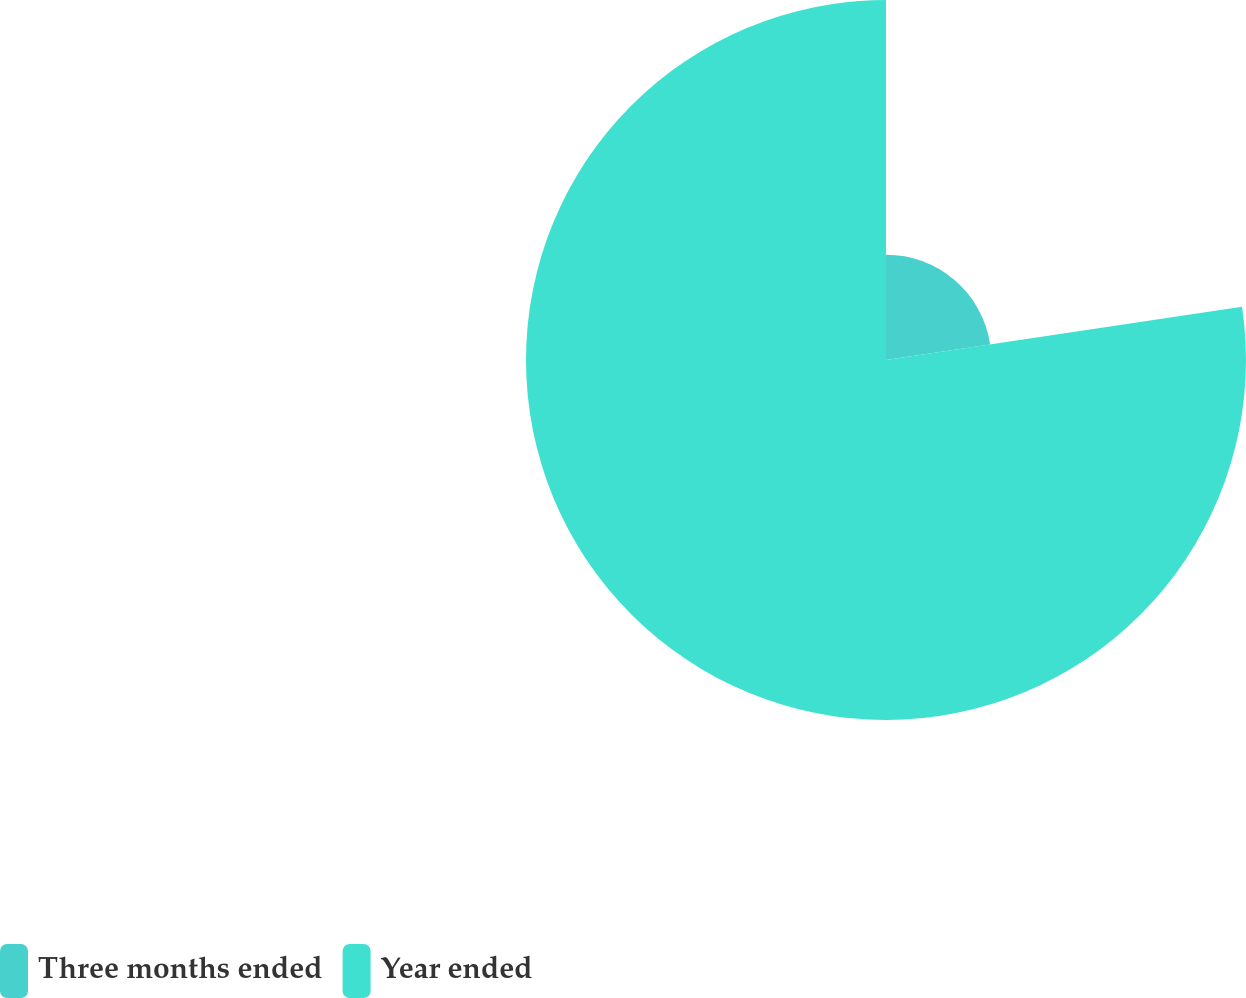Convert chart to OTSL. <chart><loc_0><loc_0><loc_500><loc_500><pie_chart><fcel>Three months ended<fcel>Year ended<nl><fcel>22.64%<fcel>77.36%<nl></chart> 